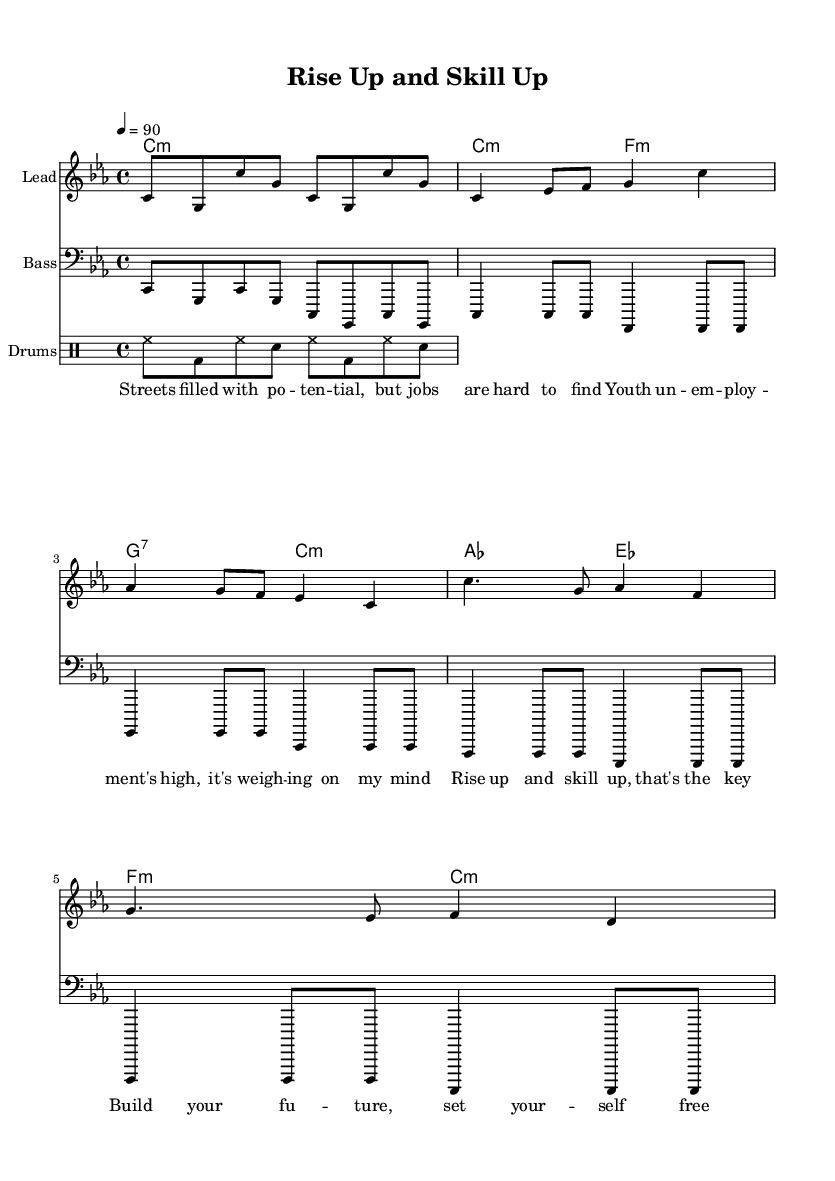What is the key signature of this music? The key signature is indicated at the beginning of the score and is C minor, which contains three flats (B♭, E♭, and A♭).
Answer: C minor What is the time signature of this music? The time signature is typically shown at the start of the score, which is common time (4/4). This means there are four beats in each measure and the quarter note gets one beat.
Answer: 4/4 What is the tempo marking for this piece? The tempo marking appears in the score, indicating the speed of the music, which in this case is marked at 90 beats per minute (BPM).
Answer: 90 How many measures are in the intro? By counting the number of measures in the introductory section of the melody part, we find there are 2 measures in the intro.
Answer: 2 What type of musical form does this piece follow? By examining the structure of the music, particularly the repetition of sections, we can determine that this piece follows a verse-chorus form, which is common in hip hop music.
Answer: Verse-Chorus What is the lyrical theme of this song? Analyzing the lyrics provided in the score, they focus on urban youth unemployment and empowerment through skills and job training, promoting the idea of rising up and building a future.
Answer: Urban youth unemployment What instrument plays the lead melody? The score indicates the staff labeled "Lead," which is usually where the principal melody is played, typically by a melodic instrument or vocal. In this case, it is designated as the Lead.
Answer: Lead 